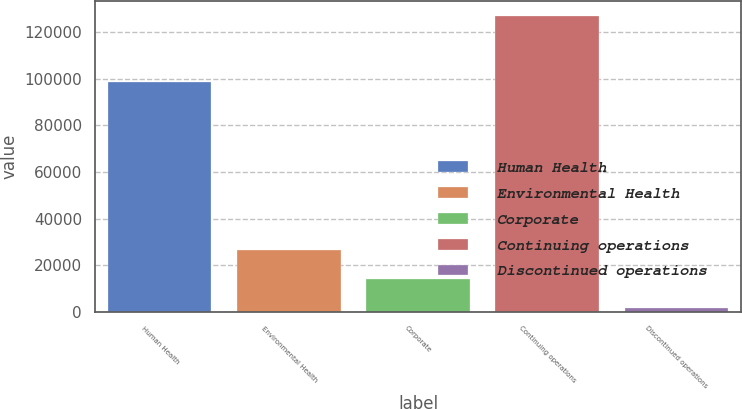Convert chart to OTSL. <chart><loc_0><loc_0><loc_500><loc_500><bar_chart><fcel>Human Health<fcel>Environmental Health<fcel>Corporate<fcel>Continuing operations<fcel>Discontinued operations<nl><fcel>98582<fcel>26647.8<fcel>14118.9<fcel>126879<fcel>1590<nl></chart> 